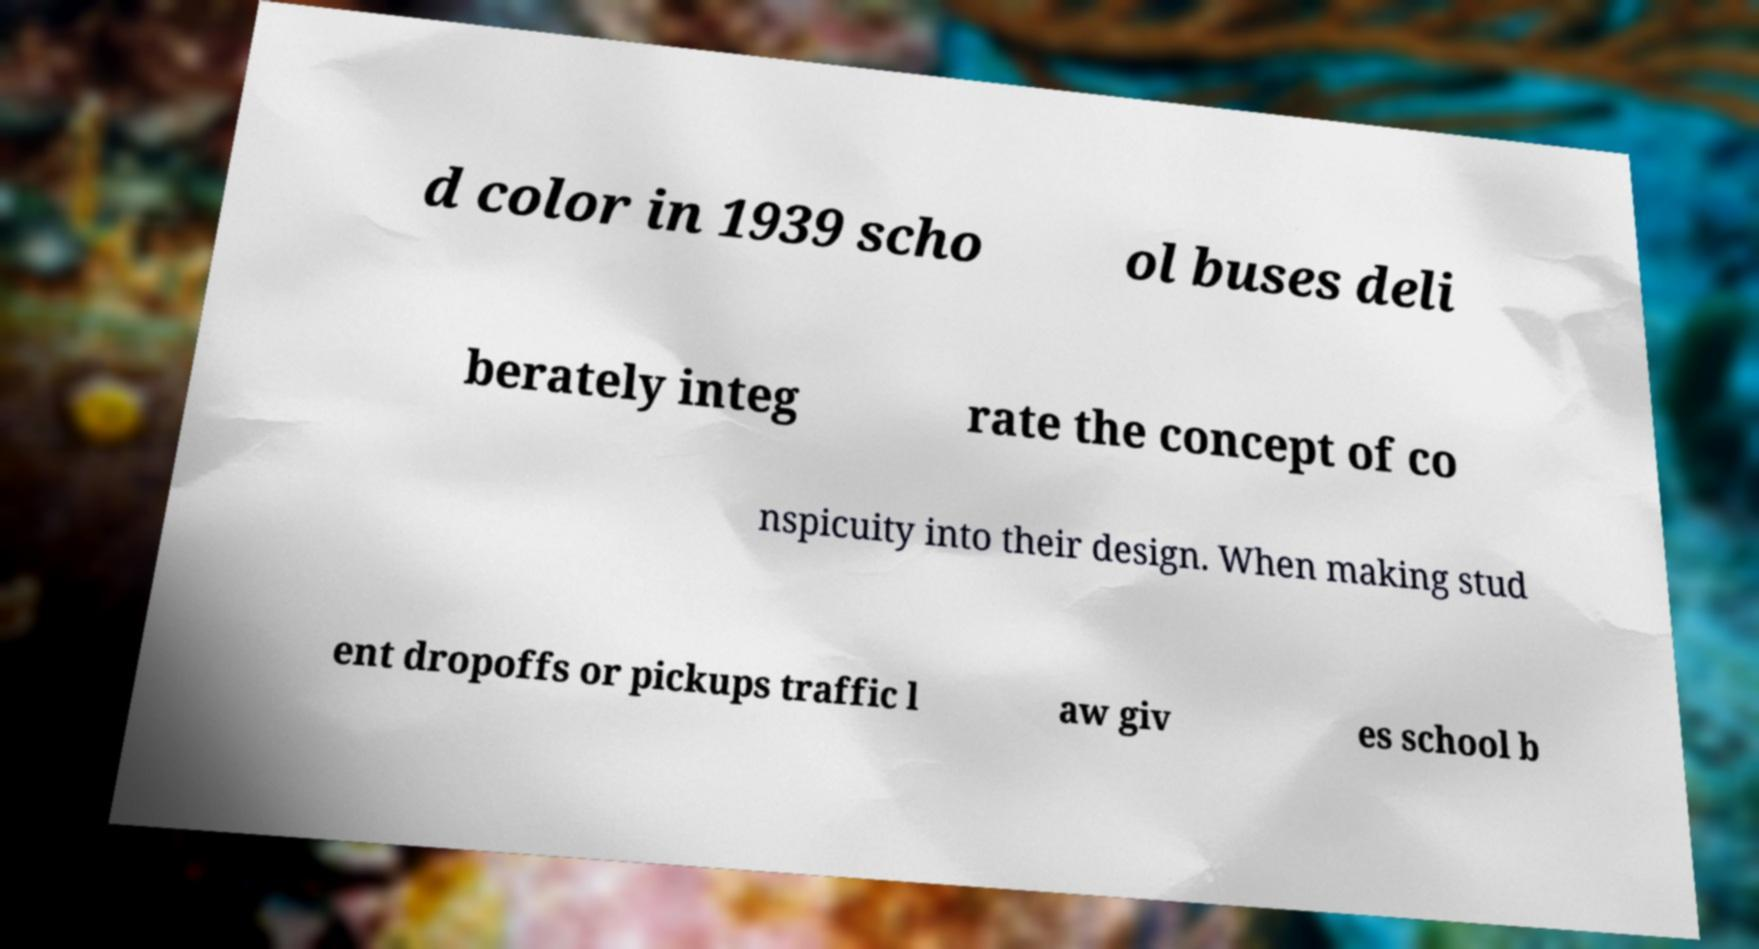Could you extract and type out the text from this image? d color in 1939 scho ol buses deli berately integ rate the concept of co nspicuity into their design. When making stud ent dropoffs or pickups traffic l aw giv es school b 